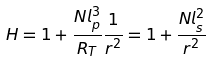<formula> <loc_0><loc_0><loc_500><loc_500>H = 1 + \frac { N l _ { p } ^ { 3 } } { R _ { T } } \frac { 1 } { r ^ { 2 } } = 1 + \frac { N l _ { s } ^ { 2 } } { r ^ { 2 } }</formula> 